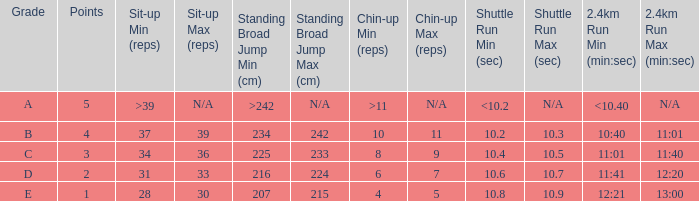Tell me the shuttle run with grade c 10.4 - 10.5. 